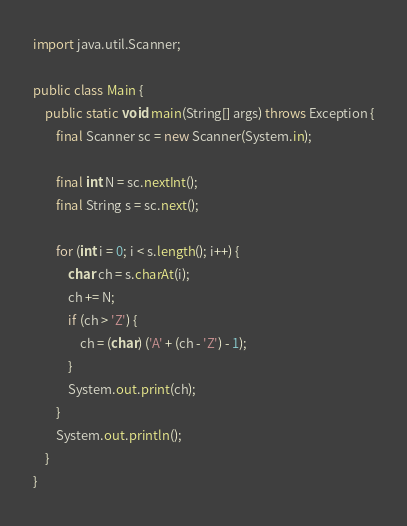Convert code to text. <code><loc_0><loc_0><loc_500><loc_500><_Java_>

import java.util.Scanner;

public class Main {
    public static void main(String[] args) throws Exception {
        final Scanner sc = new Scanner(System.in);

        final int N = sc.nextInt();
        final String s = sc.next();

        for (int i = 0; i < s.length(); i++) {
            char ch = s.charAt(i);
            ch += N;
            if (ch > 'Z') {
                ch = (char) ('A' + (ch - 'Z') - 1);
            }
            System.out.print(ch);
        }
        System.out.println();
    }
}
</code> 